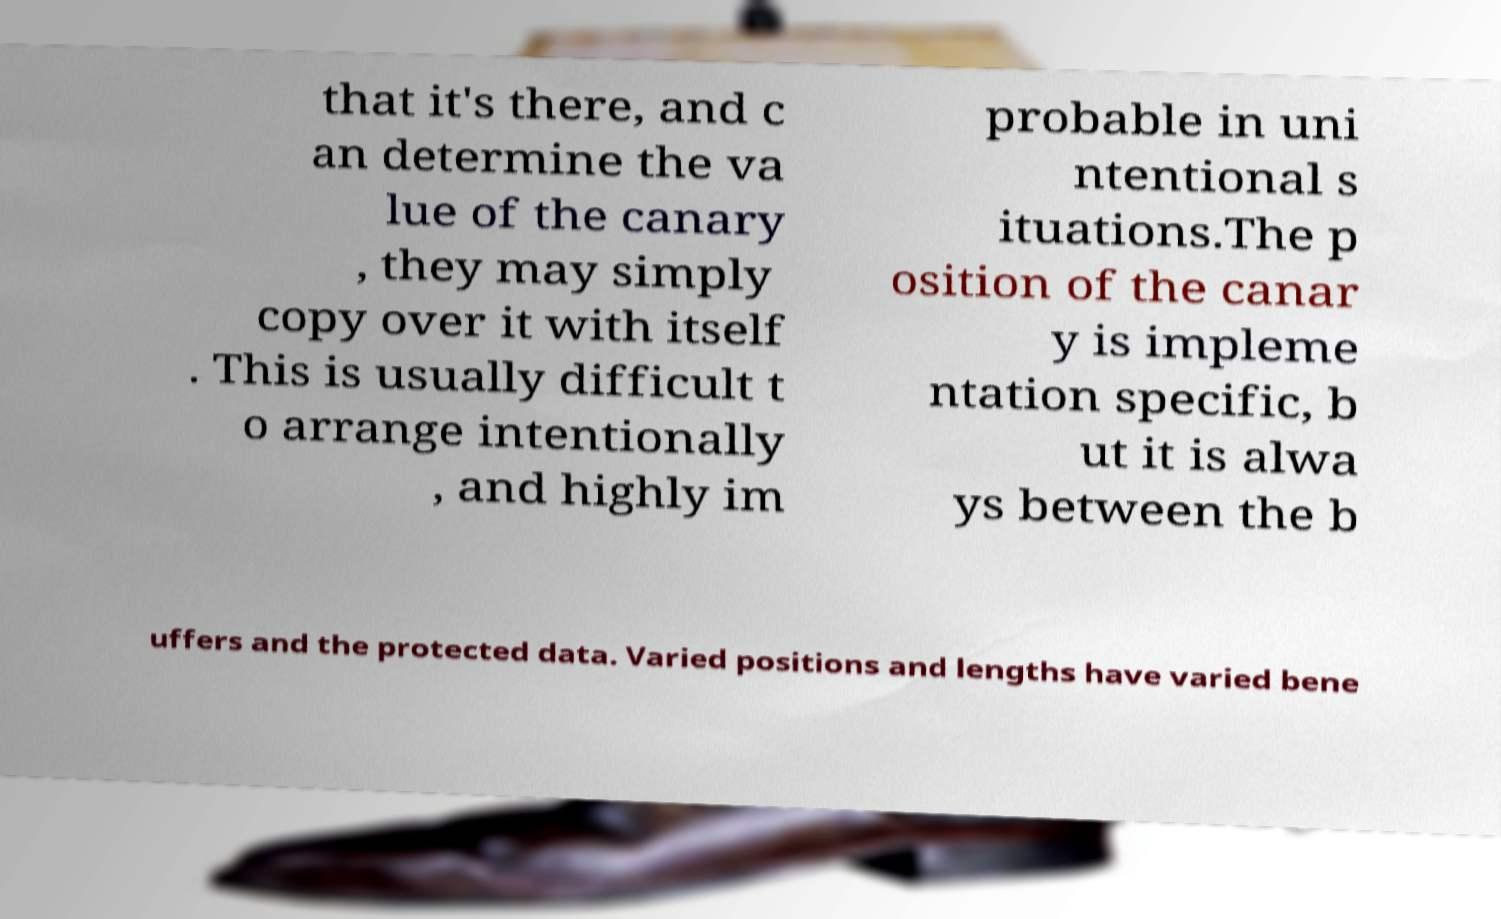Please identify and transcribe the text found in this image. that it's there, and c an determine the va lue of the canary , they may simply copy over it with itself . This is usually difficult t o arrange intentionally , and highly im probable in uni ntentional s ituations.The p osition of the canar y is impleme ntation specific, b ut it is alwa ys between the b uffers and the protected data. Varied positions and lengths have varied bene 